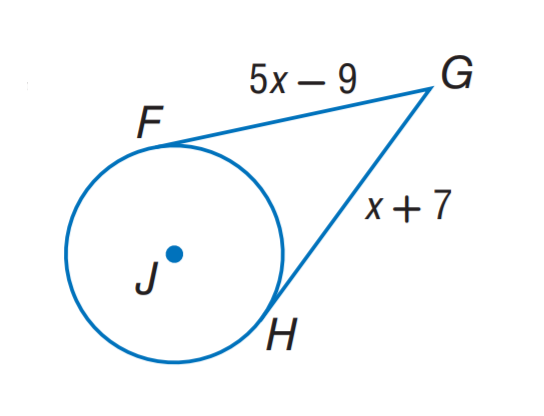Answer the mathemtical geometry problem and directly provide the correct option letter.
Question: The segment is tangent to the circle. Find x.
Choices: A: 4 B: 5 C: 7 D: 9 A 